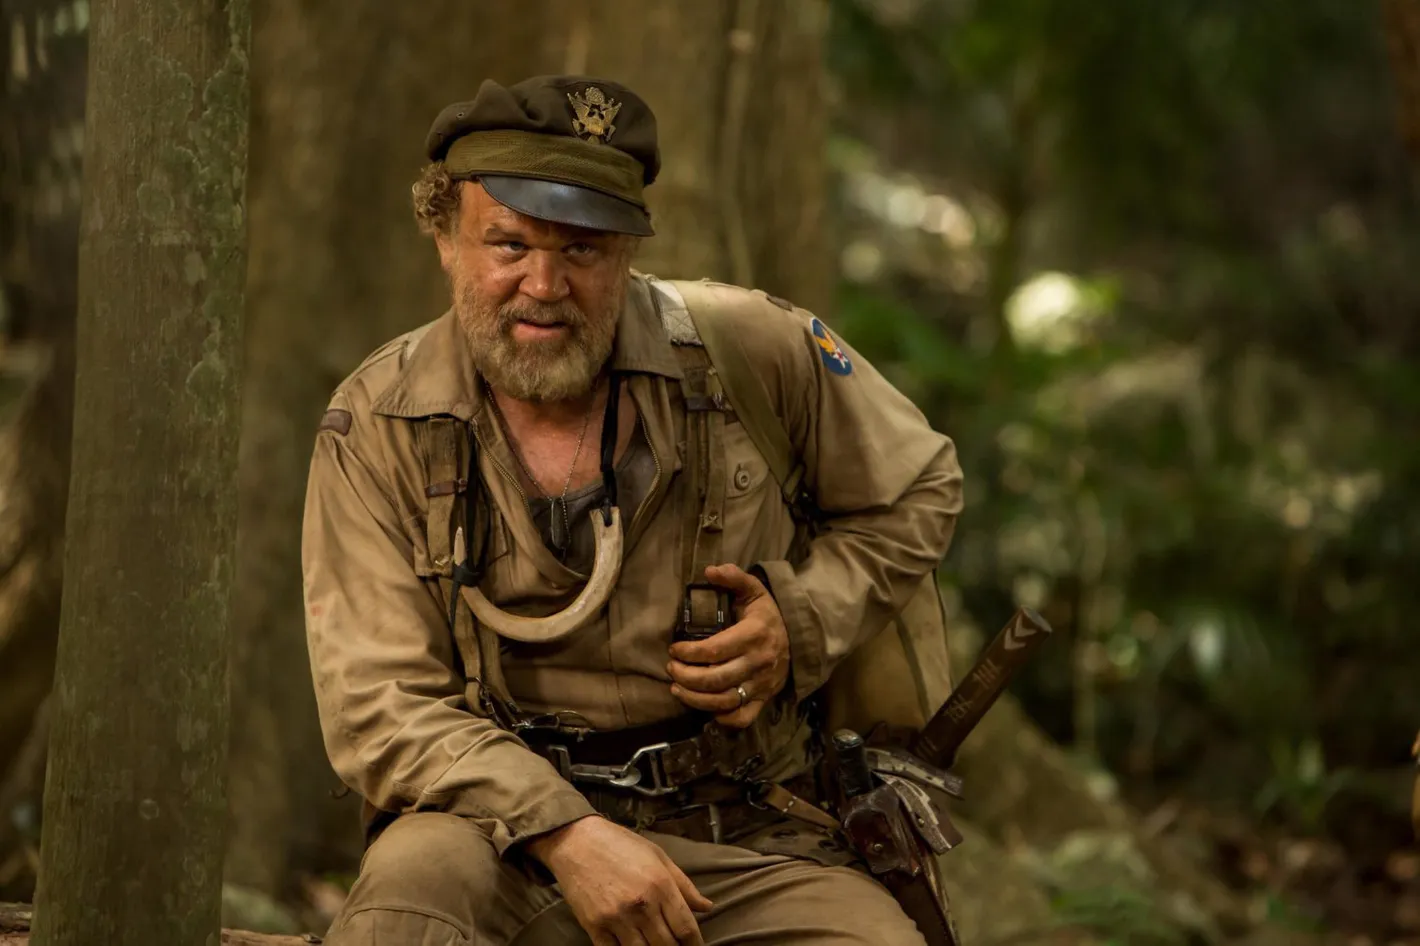What might be the daily routine and duties of this soldier? The daily routine of this soldier likely begins with a meticulous inspection of his gear at dawn, ensuring everything from his rifle to his utility knife is in optimal condition. After a quick, sparse breakfast, he’ll use his binoculars to survey the perimeter, remaining vigilant for any signs of movement. His duties might involve patrolling the area to map out potential hazards, setting up and camouflaging observation posts, and relaying strategic information to his commanders. Throughout the day, he engages in silent, stealthy movements to avoid detection, possibly documenting enemy patterns and noting environmental factors that could affect his mission. Evenings are spent coordinating with his unit via secure communication channels, planning the next day’s operations, and, when time allows, marking his location and updates on a holographic digital map. His ability to blend into the environment physically and mentally is key to his survival. During a quiet moment, what might the soldier be thinking about? During a quiet moment, the soldier might drift into thoughts of home and the loved ones he left behind. He would think of shared memories, the warmth and laughter of family gatherings, and perhaps a sense of longing for the peace and stability that once was. The forest might remind him of simpler times, possibly childhood adventures in the woods or peaceful hikes, contrasting sharply with his current reality. There might also be a sense of contemplation about the broader purpose of his mission, questioning the cost of war and the impact of his actions. He could be thinking about the future, envisioning what life might look like if he could return home safely, or what legacy he hopes to leave behind. 